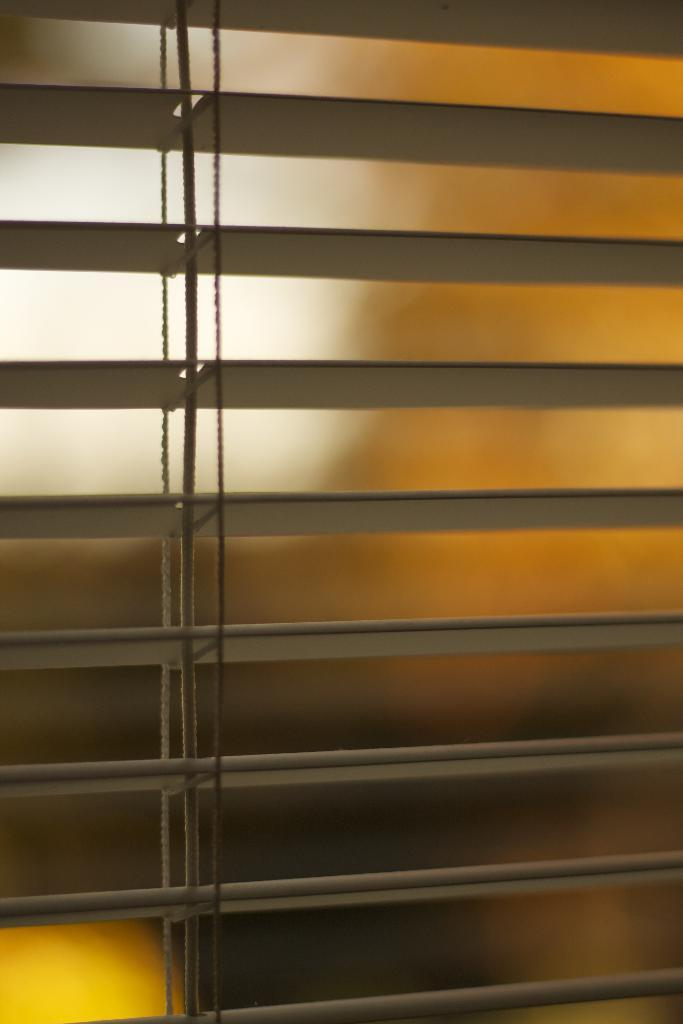What type of window treatment is visible in the image? There are blinds in the image. What material is present in the image? Thread is present in the image. How many pizzas are being delivered in the image? There are no pizzas or delivery in the image; it only features blinds and thread. What is the wish associated with the thread in the image? There is no wish associated with the thread in the image; it is simply a material present in the scene. 